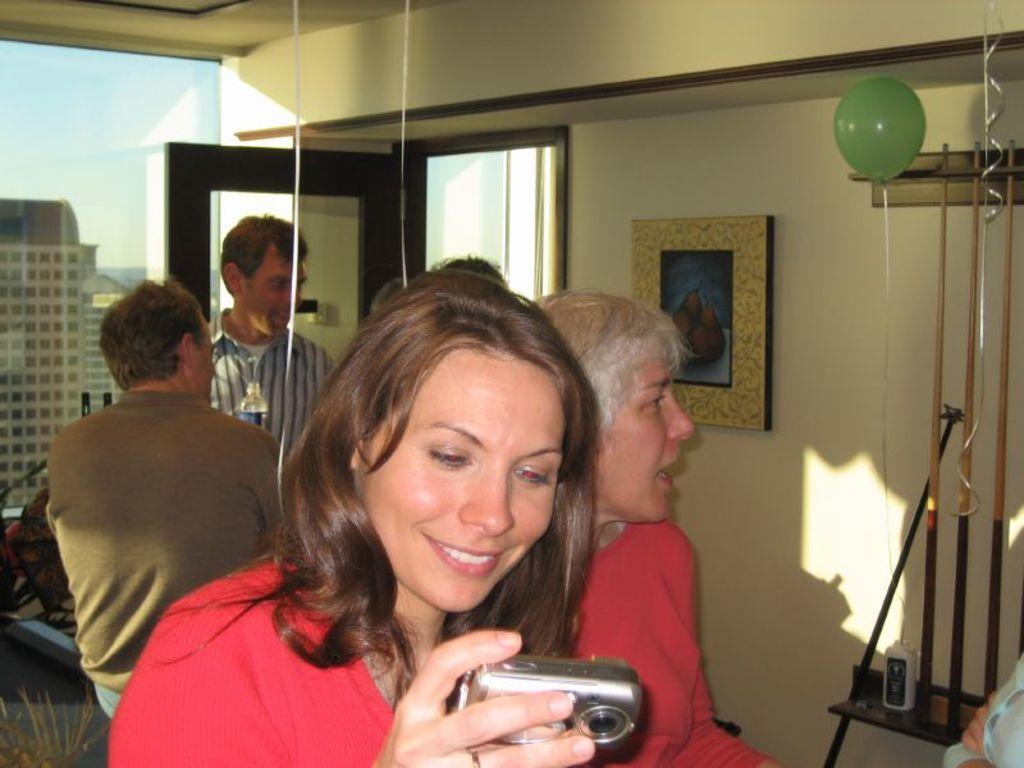Who is the main subject in the image? There is a woman in the image. What is the woman doing in the image? The woman is looking into the camera. Can you describe the person behind the woman? There is a person behind the woman, but no specific details are provided. What object is visible behind the woman? There is a water bottle behind the woman. What can be seen in the background of the image? There is a building visible in the background. What color is the creature behind the woman? There is no creature present in the image, so it is not possible to determine its color. 